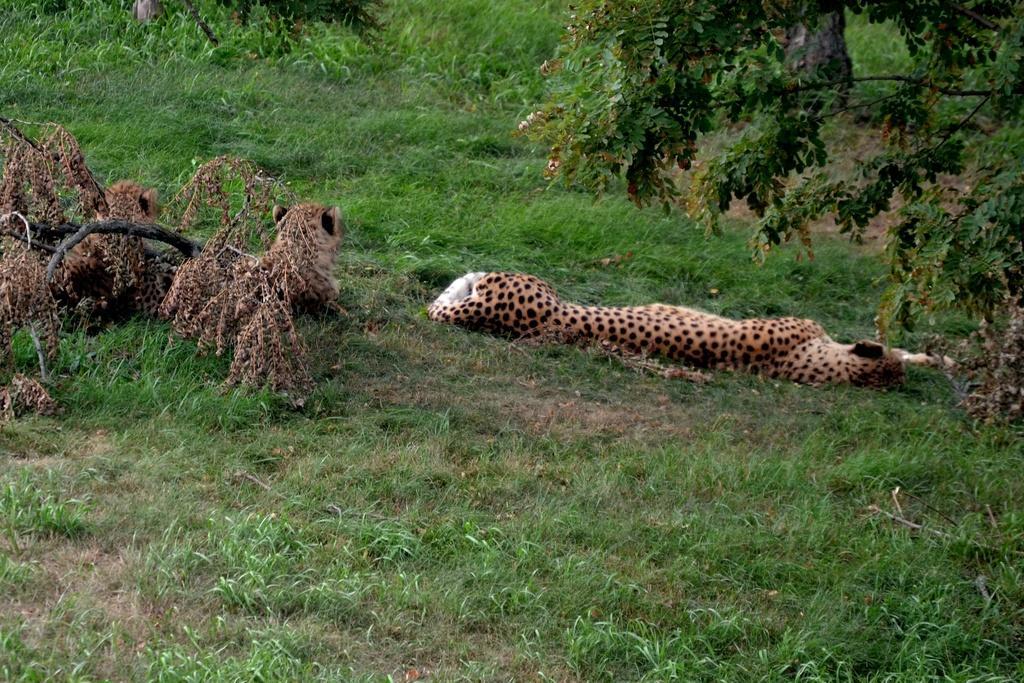How would you summarize this image in a sentence or two? In foreground we can see grass which is green in color. In middle of the image we can see dried leaves and three animals it seems to be cheetah. On the top of the we can see grass. 